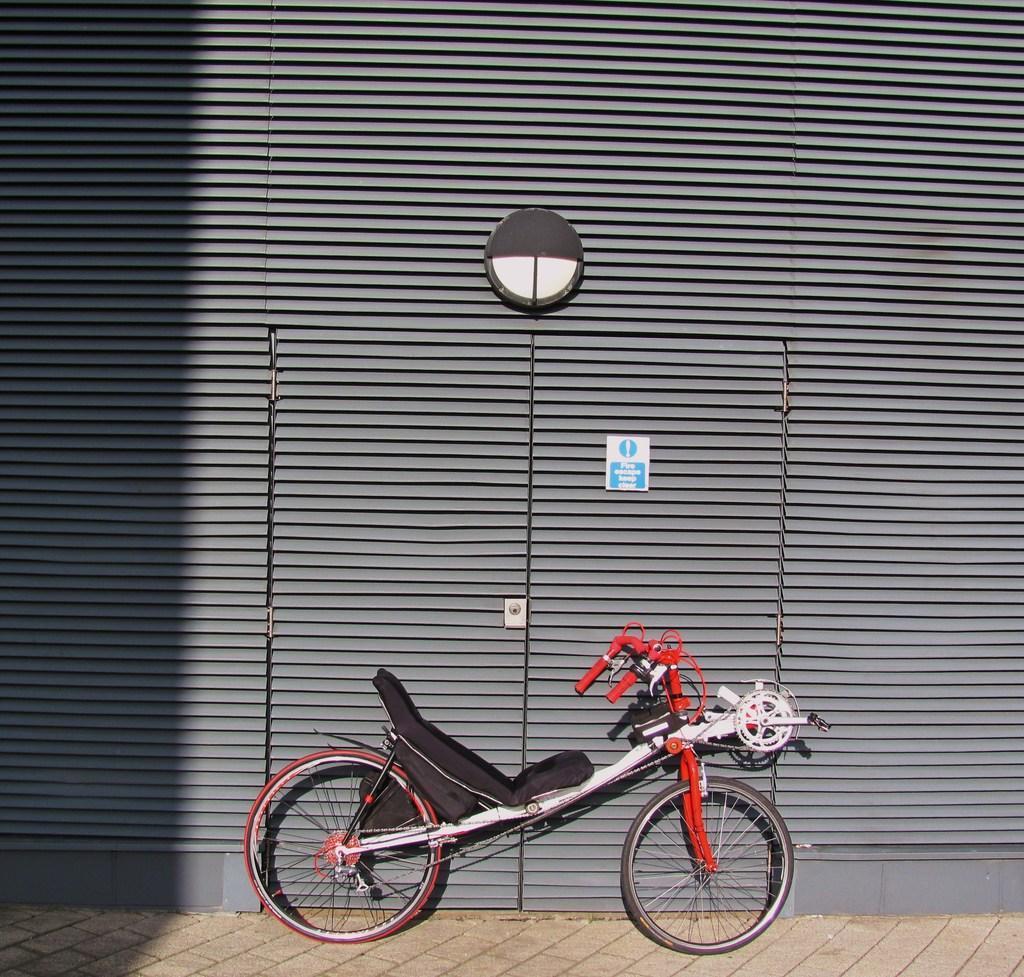How would you summarize this image in a sentence or two? At the bottom of the picture we can see bicycle and pavement. In this picture we can see wall, door and other objects. 